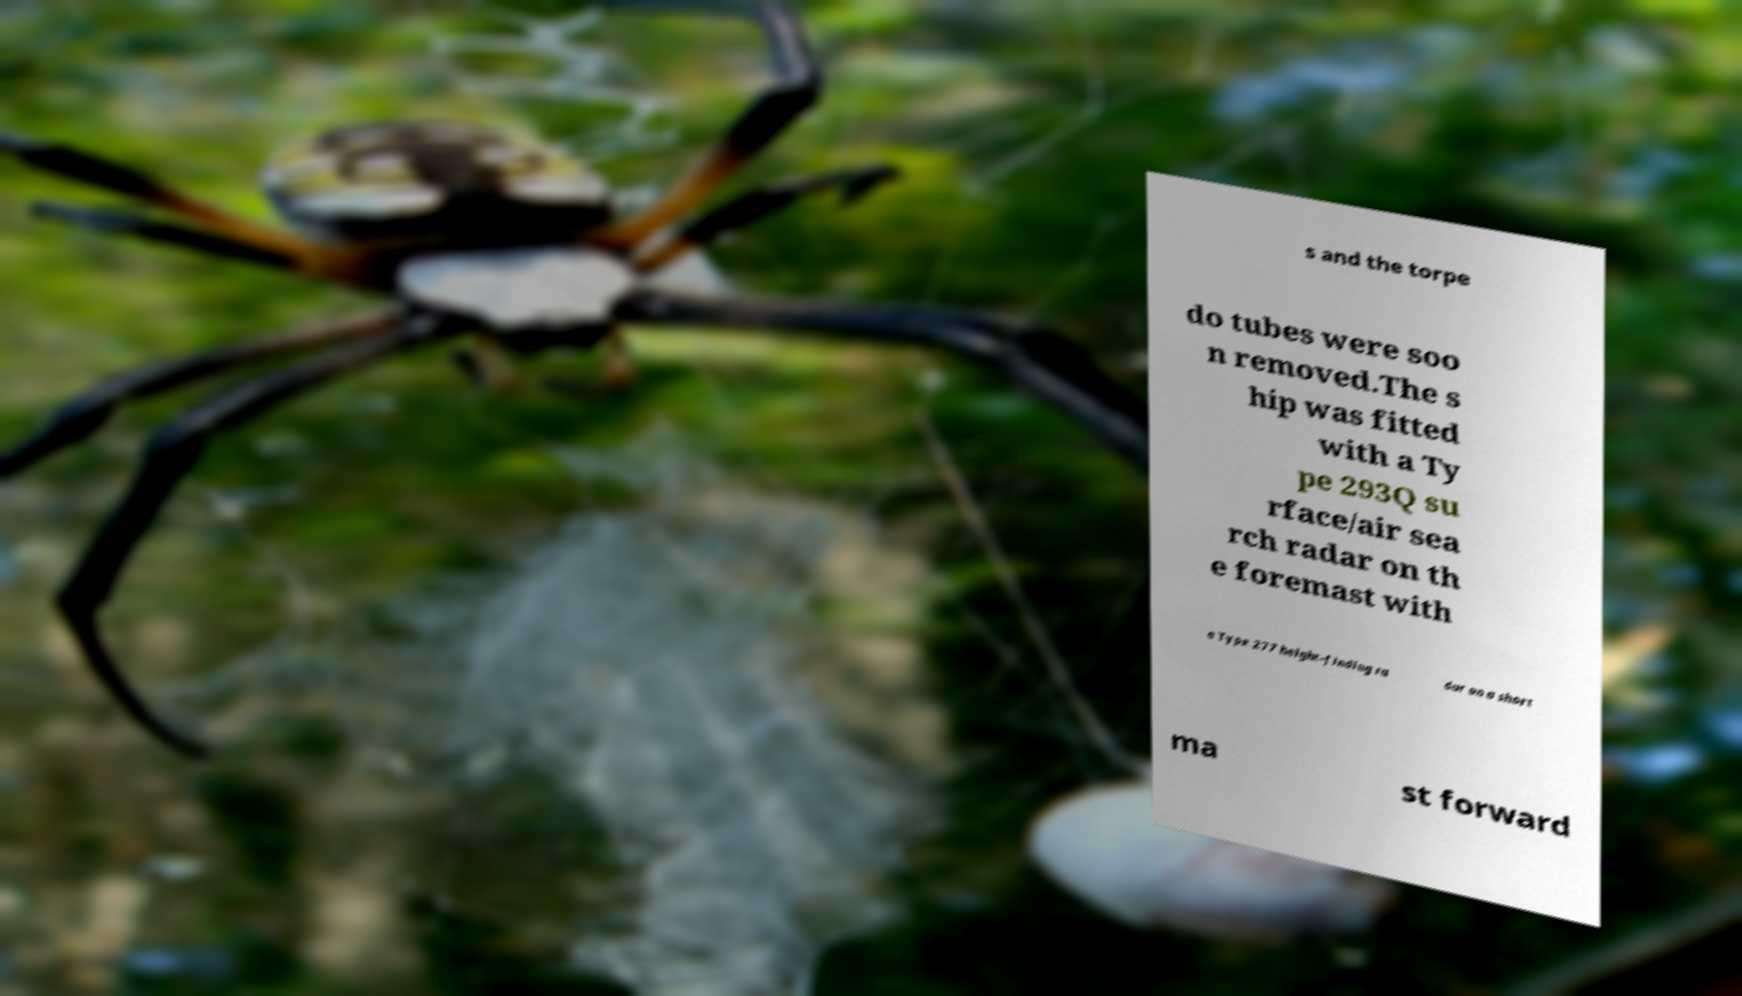Could you extract and type out the text from this image? s and the torpe do tubes were soo n removed.The s hip was fitted with a Ty pe 293Q su rface/air sea rch radar on th e foremast with a Type 277 height-finding ra dar on a short ma st forward 